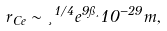Convert formula to latex. <formula><loc_0><loc_0><loc_500><loc_500>r _ { C e } \sim \xi ^ { 1 / 4 } e ^ { 9 \pi \xi } 1 0 ^ { - 2 9 } m ,</formula> 